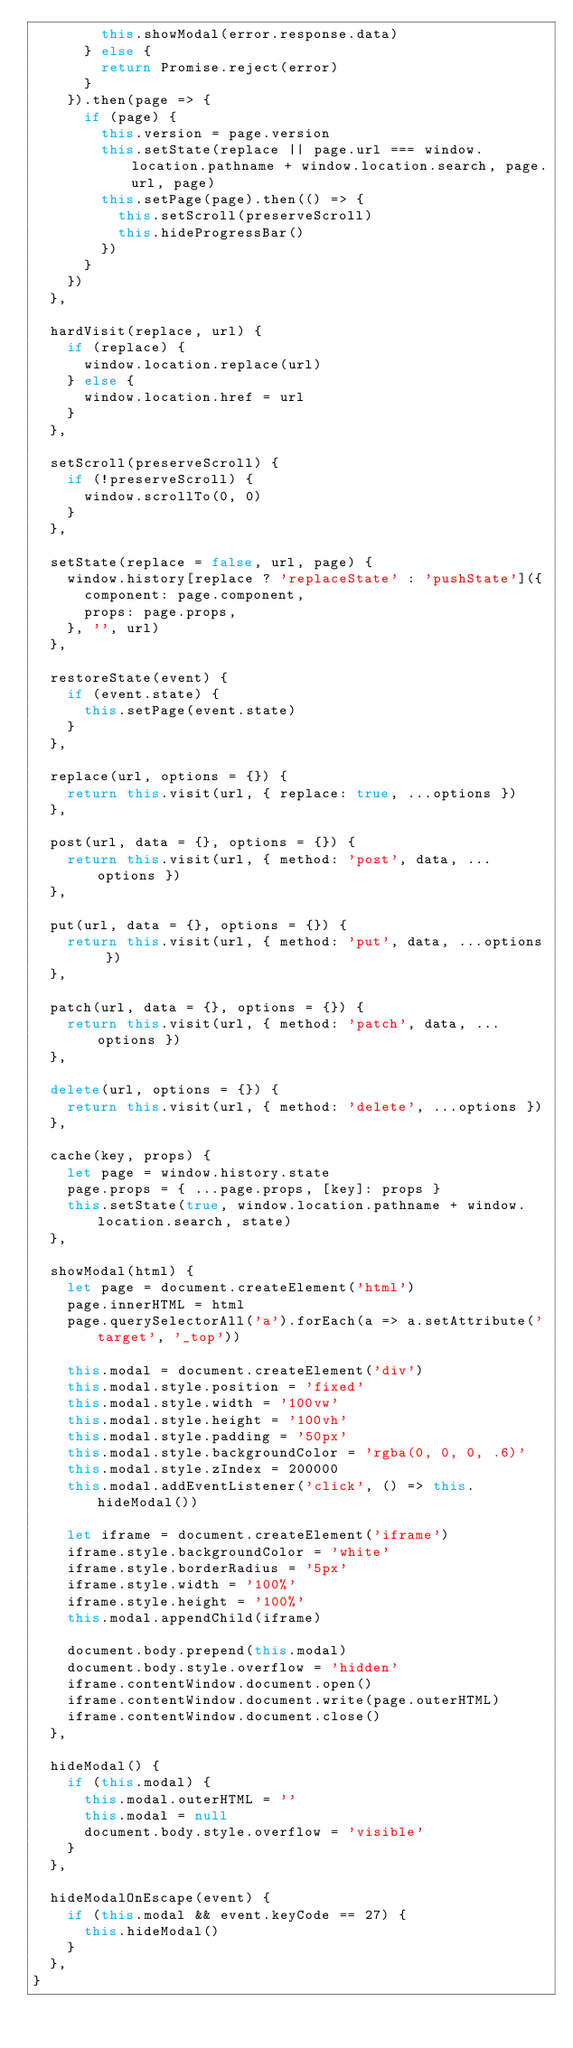<code> <loc_0><loc_0><loc_500><loc_500><_JavaScript_>        this.showModal(error.response.data)
      } else {
        return Promise.reject(error)
      }
    }).then(page => {
      if (page) {
        this.version = page.version
        this.setState(replace || page.url === window.location.pathname + window.location.search, page.url, page)
        this.setPage(page).then(() => {
          this.setScroll(preserveScroll)
          this.hideProgressBar()
        })
      }
    })
  },

  hardVisit(replace, url) {
    if (replace) {
      window.location.replace(url)
    } else {
      window.location.href = url
    }
  },

  setScroll(preserveScroll) {
    if (!preserveScroll) {
      window.scrollTo(0, 0)
    }
  },

  setState(replace = false, url, page) {
    window.history[replace ? 'replaceState' : 'pushState']({
      component: page.component,
      props: page.props,
    }, '', url)
  },

  restoreState(event) {
    if (event.state) {
      this.setPage(event.state)
    }
  },

  replace(url, options = {}) {
    return this.visit(url, { replace: true, ...options })
  },

  post(url, data = {}, options = {}) {
    return this.visit(url, { method: 'post', data, ...options })
  },

  put(url, data = {}, options = {}) {
    return this.visit(url, { method: 'put', data, ...options })
  },

  patch(url, data = {}, options = {}) {
    return this.visit(url, { method: 'patch', data, ...options })
  },

  delete(url, options = {}) {
    return this.visit(url, { method: 'delete', ...options })
  },

  cache(key, props) {
    let page = window.history.state
    page.props = { ...page.props, [key]: props }
    this.setState(true, window.location.pathname + window.location.search, state)
  },

  showModal(html) {
    let page = document.createElement('html')
    page.innerHTML = html
    page.querySelectorAll('a').forEach(a => a.setAttribute('target', '_top'))

    this.modal = document.createElement('div')
    this.modal.style.position = 'fixed'
    this.modal.style.width = '100vw'
    this.modal.style.height = '100vh'
    this.modal.style.padding = '50px'
    this.modal.style.backgroundColor = 'rgba(0, 0, 0, .6)'
    this.modal.style.zIndex = 200000
    this.modal.addEventListener('click', () => this.hideModal())

    let iframe = document.createElement('iframe')
    iframe.style.backgroundColor = 'white'
    iframe.style.borderRadius = '5px'
    iframe.style.width = '100%'
    iframe.style.height = '100%'
    this.modal.appendChild(iframe)

    document.body.prepend(this.modal)
    document.body.style.overflow = 'hidden'
    iframe.contentWindow.document.open()
    iframe.contentWindow.document.write(page.outerHTML)
    iframe.contentWindow.document.close()
  },

  hideModal() {
    if (this.modal) {
      this.modal.outerHTML = ''
      this.modal = null
      document.body.style.overflow = 'visible'
    }
  },

  hideModalOnEscape(event) {
    if (this.modal && event.keyCode == 27) {
      this.hideModal()
    }
  },
}
</code> 